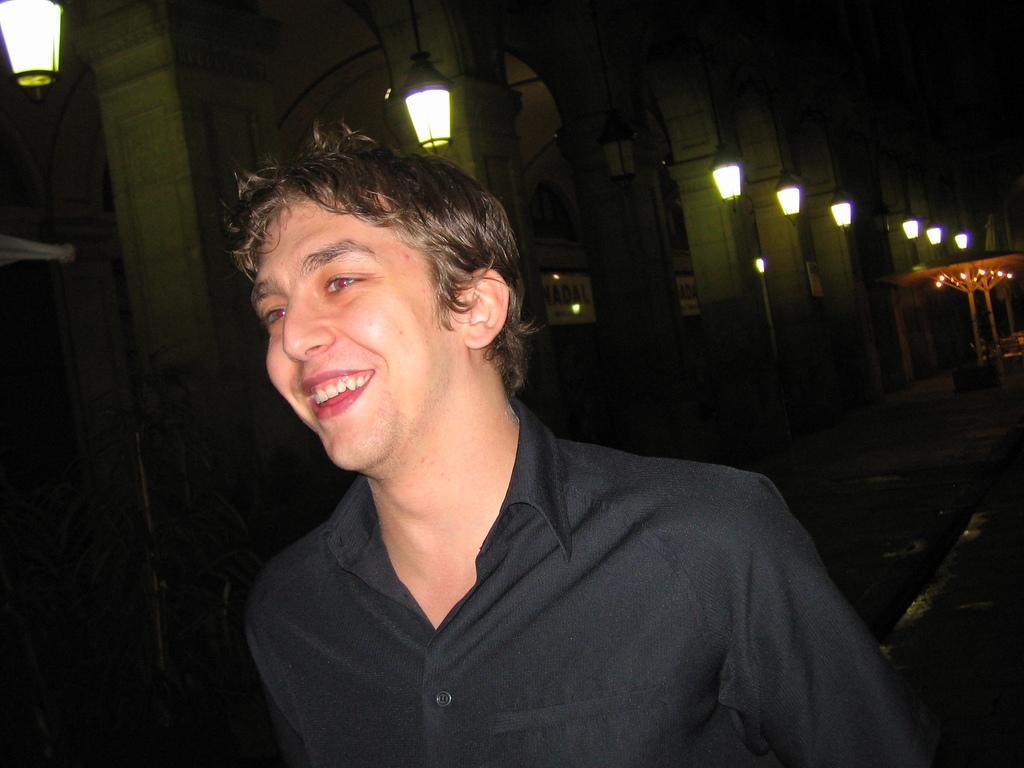Describe this image in one or two sentences. In this picture there is a man who is wearing black shirt and he is smiling. On the left there is a building. On the right i can see the lights. 